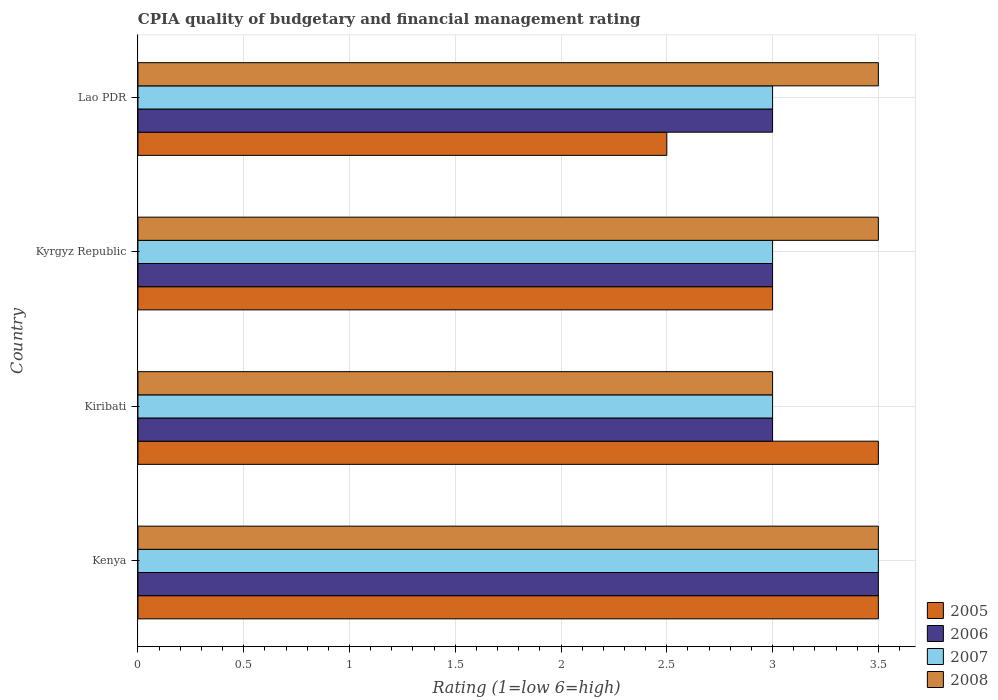How many different coloured bars are there?
Make the answer very short. 4. Are the number of bars per tick equal to the number of legend labels?
Keep it short and to the point. Yes. Are the number of bars on each tick of the Y-axis equal?
Ensure brevity in your answer.  Yes. How many bars are there on the 2nd tick from the top?
Your answer should be compact. 4. How many bars are there on the 4th tick from the bottom?
Your answer should be very brief. 4. What is the label of the 2nd group of bars from the top?
Ensure brevity in your answer.  Kyrgyz Republic. In how many cases, is the number of bars for a given country not equal to the number of legend labels?
Offer a very short reply. 0. What is the CPIA rating in 2007 in Kenya?
Provide a short and direct response. 3.5. Across all countries, what is the maximum CPIA rating in 2006?
Give a very brief answer. 3.5. In which country was the CPIA rating in 2005 maximum?
Provide a succinct answer. Kenya. In which country was the CPIA rating in 2006 minimum?
Keep it short and to the point. Kiribati. What is the difference between the CPIA rating in 2005 in Kyrgyz Republic and the CPIA rating in 2006 in Kenya?
Your answer should be compact. -0.5. What is the average CPIA rating in 2005 per country?
Keep it short and to the point. 3.12. What is the difference between the CPIA rating in 2005 and CPIA rating in 2007 in Kiribati?
Your answer should be very brief. 0.5. In how many countries, is the CPIA rating in 2006 greater than 0.30000000000000004 ?
Provide a succinct answer. 4. What is the ratio of the CPIA rating in 2006 in Kyrgyz Republic to that in Lao PDR?
Provide a short and direct response. 1. Is the CPIA rating in 2008 in Kenya less than that in Kiribati?
Your answer should be very brief. No. What is the difference between the highest and the second highest CPIA rating in 2005?
Your answer should be very brief. 0. What is the difference between the highest and the lowest CPIA rating in 2006?
Offer a terse response. 0.5. In how many countries, is the CPIA rating in 2005 greater than the average CPIA rating in 2005 taken over all countries?
Your answer should be compact. 2. Is the sum of the CPIA rating in 2005 in Kenya and Kiribati greater than the maximum CPIA rating in 2007 across all countries?
Offer a terse response. Yes. What does the 3rd bar from the top in Lao PDR represents?
Your response must be concise. 2006. What does the 2nd bar from the bottom in Lao PDR represents?
Provide a short and direct response. 2006. Are all the bars in the graph horizontal?
Make the answer very short. Yes. What is the difference between two consecutive major ticks on the X-axis?
Provide a succinct answer. 0.5. Does the graph contain any zero values?
Your answer should be compact. No. How many legend labels are there?
Give a very brief answer. 4. What is the title of the graph?
Provide a short and direct response. CPIA quality of budgetary and financial management rating. Does "2006" appear as one of the legend labels in the graph?
Your answer should be very brief. Yes. What is the Rating (1=low 6=high) of 2005 in Kenya?
Your answer should be compact. 3.5. What is the Rating (1=low 6=high) of 2006 in Kiribati?
Your response must be concise. 3. What is the Rating (1=low 6=high) of 2008 in Kiribati?
Your answer should be compact. 3. What is the Rating (1=low 6=high) of 2008 in Kyrgyz Republic?
Provide a short and direct response. 3.5. What is the Rating (1=low 6=high) of 2006 in Lao PDR?
Your response must be concise. 3. What is the Rating (1=low 6=high) in 2007 in Lao PDR?
Ensure brevity in your answer.  3. What is the Rating (1=low 6=high) in 2008 in Lao PDR?
Your response must be concise. 3.5. Across all countries, what is the maximum Rating (1=low 6=high) of 2005?
Your response must be concise. 3.5. Across all countries, what is the maximum Rating (1=low 6=high) of 2006?
Provide a short and direct response. 3.5. Across all countries, what is the maximum Rating (1=low 6=high) in 2008?
Provide a short and direct response. 3.5. Across all countries, what is the minimum Rating (1=low 6=high) of 2005?
Your answer should be very brief. 2.5. Across all countries, what is the minimum Rating (1=low 6=high) in 2006?
Offer a terse response. 3. What is the total Rating (1=low 6=high) of 2006 in the graph?
Offer a very short reply. 12.5. What is the total Rating (1=low 6=high) in 2007 in the graph?
Offer a terse response. 12.5. What is the difference between the Rating (1=low 6=high) in 2006 in Kenya and that in Kiribati?
Keep it short and to the point. 0.5. What is the difference between the Rating (1=low 6=high) of 2007 in Kenya and that in Kiribati?
Keep it short and to the point. 0.5. What is the difference between the Rating (1=low 6=high) of 2008 in Kenya and that in Kiribati?
Offer a very short reply. 0.5. What is the difference between the Rating (1=low 6=high) of 2007 in Kenya and that in Kyrgyz Republic?
Offer a terse response. 0.5. What is the difference between the Rating (1=low 6=high) in 2006 in Kenya and that in Lao PDR?
Your response must be concise. 0.5. What is the difference between the Rating (1=low 6=high) in 2008 in Kenya and that in Lao PDR?
Provide a short and direct response. 0. What is the difference between the Rating (1=low 6=high) in 2005 in Kiribati and that in Kyrgyz Republic?
Your answer should be compact. 0.5. What is the difference between the Rating (1=low 6=high) in 2005 in Kyrgyz Republic and that in Lao PDR?
Keep it short and to the point. 0.5. What is the difference between the Rating (1=low 6=high) of 2006 in Kyrgyz Republic and that in Lao PDR?
Provide a succinct answer. 0. What is the difference between the Rating (1=low 6=high) in 2008 in Kyrgyz Republic and that in Lao PDR?
Your response must be concise. 0. What is the difference between the Rating (1=low 6=high) of 2005 in Kenya and the Rating (1=low 6=high) of 2006 in Kiribati?
Your answer should be very brief. 0.5. What is the difference between the Rating (1=low 6=high) in 2005 in Kenya and the Rating (1=low 6=high) in 2007 in Kiribati?
Provide a succinct answer. 0.5. What is the difference between the Rating (1=low 6=high) in 2005 in Kenya and the Rating (1=low 6=high) in 2008 in Kiribati?
Ensure brevity in your answer.  0.5. What is the difference between the Rating (1=low 6=high) of 2006 in Kenya and the Rating (1=low 6=high) of 2007 in Kiribati?
Provide a short and direct response. 0.5. What is the difference between the Rating (1=low 6=high) of 2006 in Kenya and the Rating (1=low 6=high) of 2008 in Kiribati?
Your answer should be compact. 0.5. What is the difference between the Rating (1=low 6=high) of 2007 in Kenya and the Rating (1=low 6=high) of 2008 in Kiribati?
Keep it short and to the point. 0.5. What is the difference between the Rating (1=low 6=high) of 2005 in Kenya and the Rating (1=low 6=high) of 2006 in Kyrgyz Republic?
Your response must be concise. 0.5. What is the difference between the Rating (1=low 6=high) in 2007 in Kenya and the Rating (1=low 6=high) in 2008 in Kyrgyz Republic?
Keep it short and to the point. 0. What is the difference between the Rating (1=low 6=high) in 2005 in Kenya and the Rating (1=low 6=high) in 2006 in Lao PDR?
Your answer should be compact. 0.5. What is the difference between the Rating (1=low 6=high) in 2005 in Kenya and the Rating (1=low 6=high) in 2007 in Lao PDR?
Give a very brief answer. 0.5. What is the difference between the Rating (1=low 6=high) in 2006 in Kenya and the Rating (1=low 6=high) in 2008 in Lao PDR?
Provide a succinct answer. 0. What is the difference between the Rating (1=low 6=high) in 2006 in Kiribati and the Rating (1=low 6=high) in 2007 in Kyrgyz Republic?
Give a very brief answer. 0. What is the difference between the Rating (1=low 6=high) of 2005 in Kiribati and the Rating (1=low 6=high) of 2007 in Lao PDR?
Make the answer very short. 0.5. What is the difference between the Rating (1=low 6=high) of 2005 in Kiribati and the Rating (1=low 6=high) of 2008 in Lao PDR?
Ensure brevity in your answer.  0. What is the difference between the Rating (1=low 6=high) in 2006 in Kiribati and the Rating (1=low 6=high) in 2007 in Lao PDR?
Provide a short and direct response. 0. What is the difference between the Rating (1=low 6=high) in 2006 in Kiribati and the Rating (1=low 6=high) in 2008 in Lao PDR?
Give a very brief answer. -0.5. What is the difference between the Rating (1=low 6=high) in 2007 in Kiribati and the Rating (1=low 6=high) in 2008 in Lao PDR?
Keep it short and to the point. -0.5. What is the difference between the Rating (1=low 6=high) of 2005 in Kyrgyz Republic and the Rating (1=low 6=high) of 2006 in Lao PDR?
Ensure brevity in your answer.  0. What is the difference between the Rating (1=low 6=high) in 2005 in Kyrgyz Republic and the Rating (1=low 6=high) in 2007 in Lao PDR?
Make the answer very short. 0. What is the difference between the Rating (1=low 6=high) in 2007 in Kyrgyz Republic and the Rating (1=low 6=high) in 2008 in Lao PDR?
Keep it short and to the point. -0.5. What is the average Rating (1=low 6=high) in 2005 per country?
Give a very brief answer. 3.12. What is the average Rating (1=low 6=high) of 2006 per country?
Your answer should be very brief. 3.12. What is the average Rating (1=low 6=high) in 2007 per country?
Ensure brevity in your answer.  3.12. What is the average Rating (1=low 6=high) of 2008 per country?
Give a very brief answer. 3.38. What is the difference between the Rating (1=low 6=high) of 2005 and Rating (1=low 6=high) of 2007 in Kenya?
Your answer should be compact. 0. What is the difference between the Rating (1=low 6=high) of 2005 and Rating (1=low 6=high) of 2008 in Kenya?
Offer a terse response. 0. What is the difference between the Rating (1=low 6=high) in 2006 and Rating (1=low 6=high) in 2007 in Kenya?
Your answer should be compact. 0. What is the difference between the Rating (1=low 6=high) in 2007 and Rating (1=low 6=high) in 2008 in Kenya?
Offer a very short reply. 0. What is the difference between the Rating (1=low 6=high) in 2005 and Rating (1=low 6=high) in 2006 in Kiribati?
Ensure brevity in your answer.  0.5. What is the difference between the Rating (1=low 6=high) of 2005 and Rating (1=low 6=high) of 2007 in Kiribati?
Give a very brief answer. 0.5. What is the difference between the Rating (1=low 6=high) of 2005 and Rating (1=low 6=high) of 2008 in Kiribati?
Provide a short and direct response. 0.5. What is the difference between the Rating (1=low 6=high) in 2006 and Rating (1=low 6=high) in 2007 in Kiribati?
Keep it short and to the point. 0. What is the difference between the Rating (1=low 6=high) in 2005 and Rating (1=low 6=high) in 2006 in Kyrgyz Republic?
Make the answer very short. 0. What is the difference between the Rating (1=low 6=high) in 2005 and Rating (1=low 6=high) in 2007 in Kyrgyz Republic?
Keep it short and to the point. 0. What is the difference between the Rating (1=low 6=high) in 2005 and Rating (1=low 6=high) in 2008 in Kyrgyz Republic?
Offer a terse response. -0.5. What is the difference between the Rating (1=low 6=high) of 2007 and Rating (1=low 6=high) of 2008 in Kyrgyz Republic?
Provide a short and direct response. -0.5. What is the difference between the Rating (1=low 6=high) of 2005 and Rating (1=low 6=high) of 2006 in Lao PDR?
Your response must be concise. -0.5. What is the difference between the Rating (1=low 6=high) of 2005 and Rating (1=low 6=high) of 2007 in Lao PDR?
Ensure brevity in your answer.  -0.5. What is the difference between the Rating (1=low 6=high) in 2005 and Rating (1=low 6=high) in 2008 in Lao PDR?
Ensure brevity in your answer.  -1. What is the difference between the Rating (1=low 6=high) of 2007 and Rating (1=low 6=high) of 2008 in Lao PDR?
Ensure brevity in your answer.  -0.5. What is the ratio of the Rating (1=low 6=high) of 2005 in Kenya to that in Kiribati?
Offer a very short reply. 1. What is the ratio of the Rating (1=low 6=high) in 2007 in Kenya to that in Kiribati?
Keep it short and to the point. 1.17. What is the ratio of the Rating (1=low 6=high) in 2005 in Kenya to that in Kyrgyz Republic?
Ensure brevity in your answer.  1.17. What is the ratio of the Rating (1=low 6=high) in 2008 in Kenya to that in Kyrgyz Republic?
Your response must be concise. 1. What is the ratio of the Rating (1=low 6=high) of 2005 in Kenya to that in Lao PDR?
Ensure brevity in your answer.  1.4. What is the ratio of the Rating (1=low 6=high) in 2007 in Kenya to that in Lao PDR?
Your response must be concise. 1.17. What is the ratio of the Rating (1=low 6=high) of 2008 in Kenya to that in Lao PDR?
Offer a terse response. 1. What is the ratio of the Rating (1=low 6=high) of 2005 in Kiribati to that in Lao PDR?
Give a very brief answer. 1.4. What is the ratio of the Rating (1=low 6=high) in 2006 in Kiribati to that in Lao PDR?
Provide a short and direct response. 1. What is the ratio of the Rating (1=low 6=high) in 2005 in Kyrgyz Republic to that in Lao PDR?
Provide a short and direct response. 1.2. What is the ratio of the Rating (1=low 6=high) of 2008 in Kyrgyz Republic to that in Lao PDR?
Make the answer very short. 1. What is the difference between the highest and the second highest Rating (1=low 6=high) of 2006?
Your response must be concise. 0.5. What is the difference between the highest and the lowest Rating (1=low 6=high) of 2005?
Offer a very short reply. 1. What is the difference between the highest and the lowest Rating (1=low 6=high) in 2006?
Your answer should be very brief. 0.5. What is the difference between the highest and the lowest Rating (1=low 6=high) of 2008?
Your answer should be compact. 0.5. 